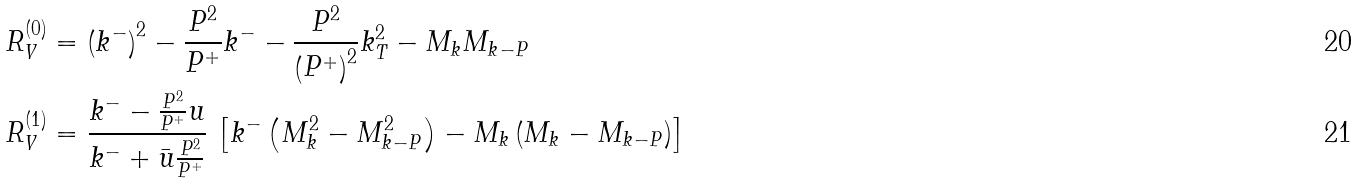Convert formula to latex. <formula><loc_0><loc_0><loc_500><loc_500>R _ { V } ^ { ( 0 ) } & = \left ( k ^ { - } \right ) ^ { 2 } - \frac { P ^ { 2 } } { P ^ { + } } k ^ { - } - \frac { P ^ { 2 } } { \left ( P ^ { + } \right ) ^ { 2 } } k _ { T } ^ { 2 } - M _ { k } M _ { k - P } \\ R _ { V } ^ { ( 1 ) } & = \frac { k ^ { - } - \frac { P ^ { 2 } } { P ^ { + } } u } { k ^ { - } + \bar { u } \frac { P ^ { 2 } } { P ^ { + } } } \, \left [ k ^ { - } \left ( M ^ { 2 } _ { k } - M ^ { 2 } _ { k - P } \right ) - M _ { k } \left ( M _ { k } - M _ { k - P } \right ) \right ]</formula> 